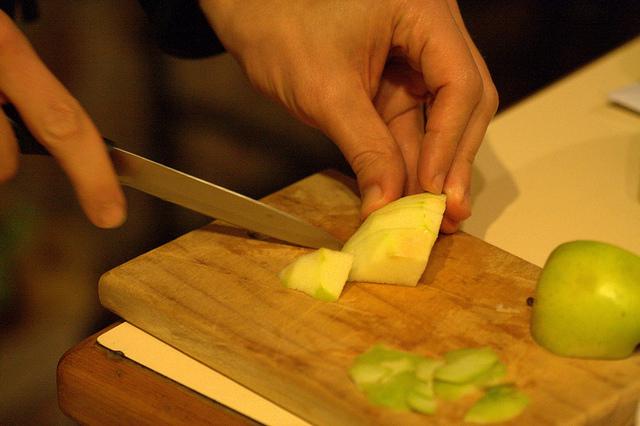What utensil is pictured?
Write a very short answer. Knife. What object in the photo is edible?
Concise answer only. Apple. Was the apple sliced or chopped?
Quick response, please. Chopped. What kind of apple is it?
Keep it brief. Green. What vegetable is being cut?
Write a very short answer. Apple. What is the person doing?
Short answer required. Cutting apple. 